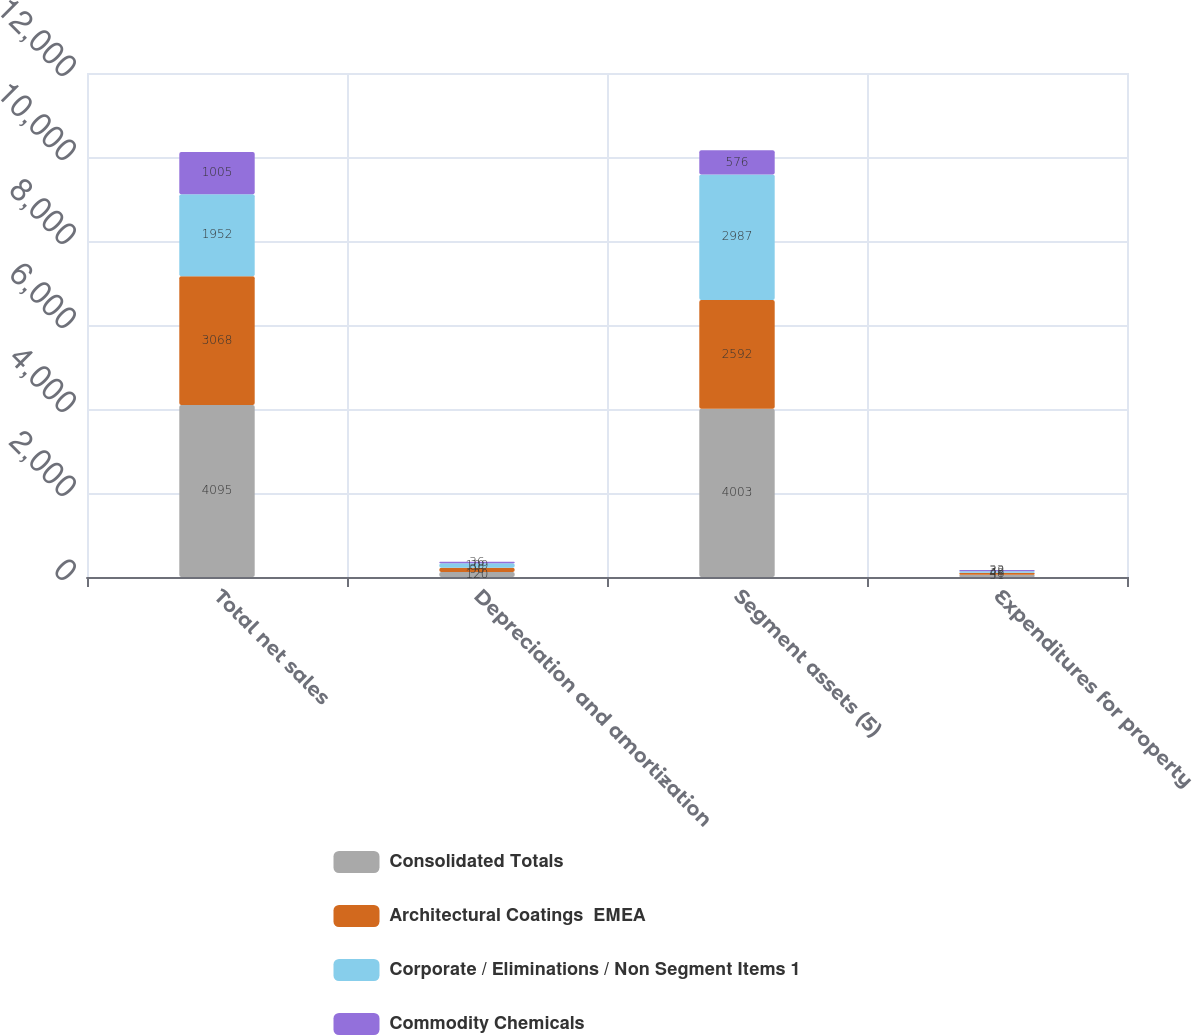Convert chart. <chart><loc_0><loc_0><loc_500><loc_500><stacked_bar_chart><ecel><fcel>Total net sales<fcel>Depreciation and amortization<fcel>Segment assets (5)<fcel>Expenditures for property<nl><fcel>Consolidated Totals<fcel>4095<fcel>120<fcel>4003<fcel>51<nl><fcel>Architectural Coatings  EMEA<fcel>3068<fcel>98<fcel>2592<fcel>48<nl><fcel>Corporate / Eliminations / Non Segment Items 1<fcel>1952<fcel>109<fcel>2987<fcel>38<nl><fcel>Commodity Chemicals<fcel>1005<fcel>36<fcel>576<fcel>32<nl></chart> 